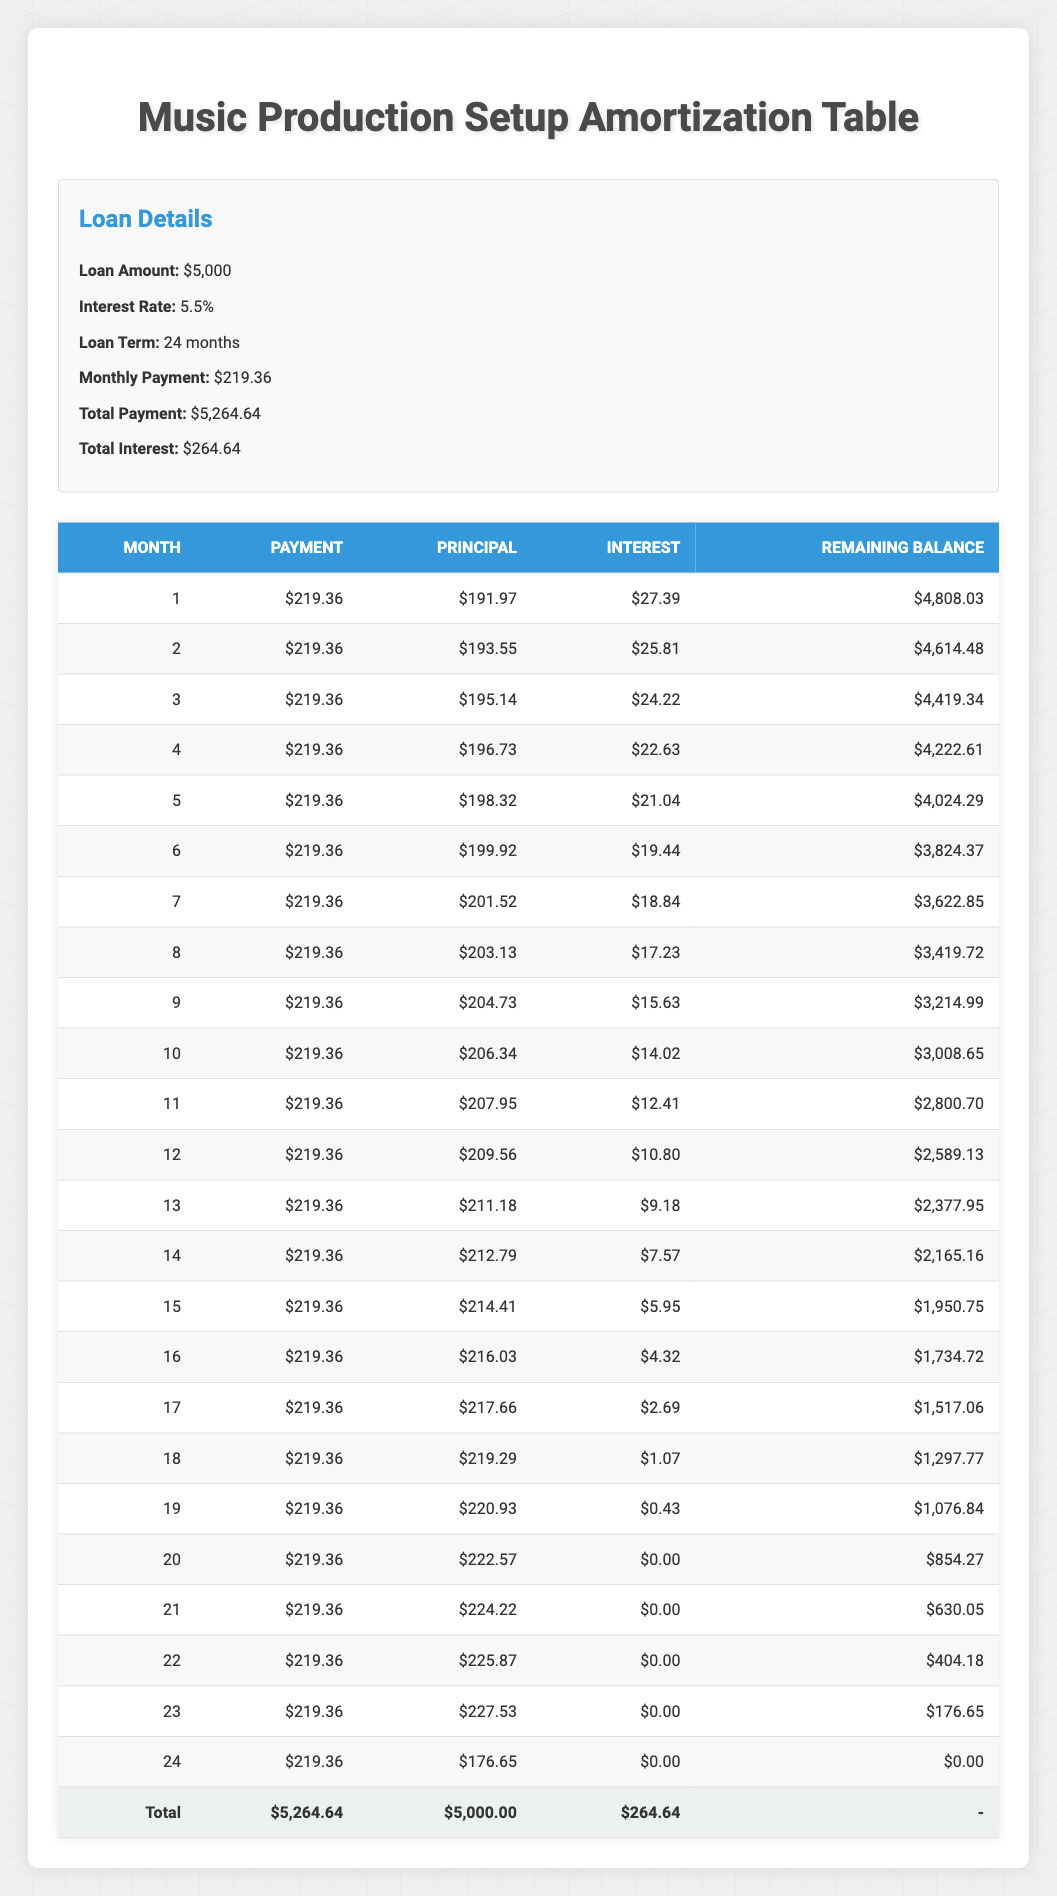What is the total payment amount over the loan term? The total payment amount is given in the loan details section of the table, which states that the total payment is $5,264.64.
Answer: 5,264.64 What is the monthly payment for the loan? The monthly payment is explicitly mentioned in the loan details section as $219.36.
Answer: 219.36 How much interest is paid in the first month? In the first month, the interest paid is listed as $27.39 in the payment schedule.
Answer: 27.39 What is the principal repayment in the 12th month? The principal repayment for the 12th month is shown in the payment schedule as $209.56.
Answer: 209.56 On average, how much principal is repaid each month over the loan term? To find the average principal repayment, sum the principal repayments from all months (which totals $5,000) and divide by the loan term (24 months). Therefore, the average principal repaid each month is $5,000/24 ≈ $208.33.
Answer: 208.33 Did the monthly payment amount ever decrease during the loan term? Reviewing the payment schedule, it shows that the monthly payment remains constant at $219.36 throughout the term, indicating that it never decreased.
Answer: No How much total interest is paid over the arrangement of the loan? The total interest is directly provided in the loan details section, which states the total interest over the loan term is $264.64.
Answer: 264.64 What was the remaining balance after the 6th month? Referring to the payment schedule, the remaining balance after the 6th month is given as $3,824.37.
Answer: 3,824.37 In which month was the principal repayment the highest? Analyzing the principal repayment amounts month by month, the highest principal repayment is seen in the 23rd month at $227.53.
Answer: 23 What is the difference between the total payment and total interest? The difference between the total payment and total interest can be calculated as $5,264.64 (total payment) - $264.64 (total interest) = $5,000. Therefore, the difference is $5,000.
Answer: 5,000 